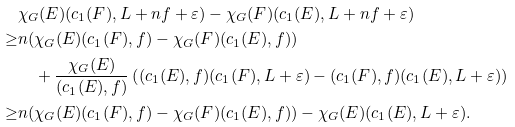Convert formula to latex. <formula><loc_0><loc_0><loc_500><loc_500>& \chi _ { G } ( E ) ( c _ { 1 } ( F ) , L + n f + \varepsilon ) - \chi _ { G } ( F ) ( c _ { 1 } ( E ) , L + n f + \varepsilon ) \\ \geq & n ( \chi _ { G } ( E ) ( c _ { 1 } ( F ) , f ) - \chi _ { G } ( F ) ( c _ { 1 } ( E ) , f ) ) \\ & \quad + \frac { \chi _ { G } ( E ) } { ( c _ { 1 } ( E ) , f ) } \left ( ( c _ { 1 } ( E ) , f ) ( c _ { 1 } ( F ) , L + \varepsilon ) - ( c _ { 1 } ( F ) , f ) ( c _ { 1 } ( E ) , L + \varepsilon ) \right ) \\ \geq & n ( \chi _ { G } ( E ) ( c _ { 1 } ( F ) , f ) - \chi _ { G } ( F ) ( c _ { 1 } ( E ) , f ) ) - \chi _ { G } ( E ) ( c _ { 1 } ( E ) , L + \varepsilon ) .</formula> 